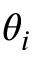Convert formula to latex. <formula><loc_0><loc_0><loc_500><loc_500>\theta _ { i }</formula> 